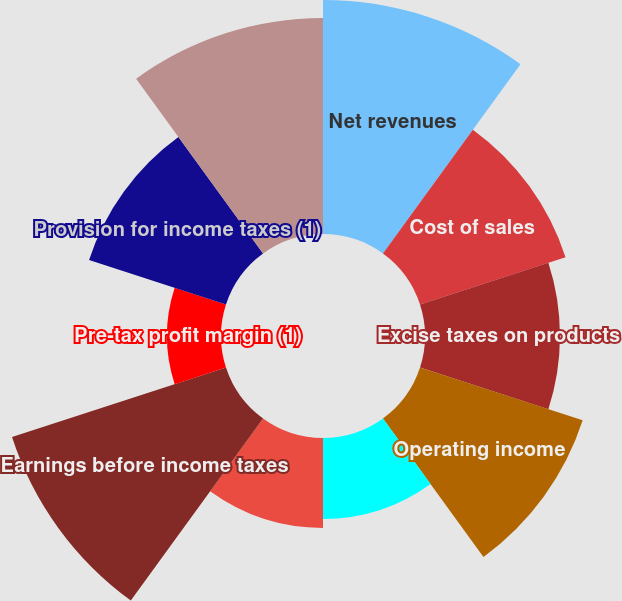Convert chart to OTSL. <chart><loc_0><loc_0><loc_500><loc_500><pie_chart><fcel>Net revenues<fcel>Cost of sales<fcel>Excise taxes on products<fcel>Operating income<fcel>Interest and other debt<fcel>Earnings from equity<fcel>Earnings before income taxes<fcel>Pre-tax profit margin (1)<fcel>Provision for income taxes (1)<fcel>Net earnings (1)<nl><fcel>15.57%<fcel>10.18%<fcel>8.98%<fcel>11.38%<fcel>5.39%<fcel>5.99%<fcel>14.97%<fcel>3.59%<fcel>9.58%<fcel>14.37%<nl></chart> 